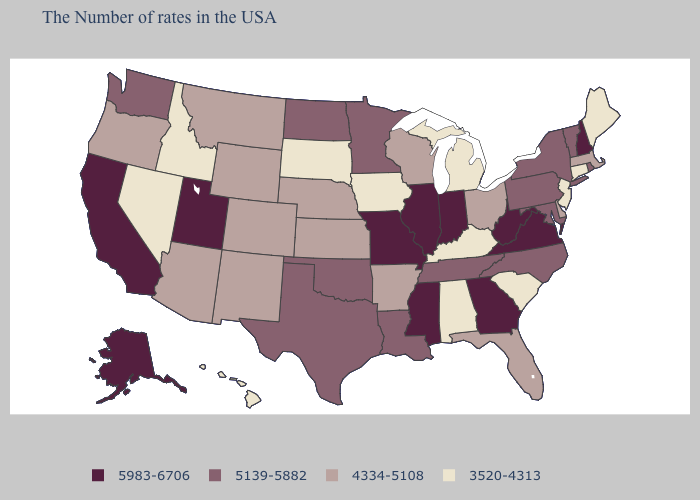Name the states that have a value in the range 3520-4313?
Answer briefly. Maine, Connecticut, New Jersey, South Carolina, Michigan, Kentucky, Alabama, Iowa, South Dakota, Idaho, Nevada, Hawaii. Name the states that have a value in the range 5983-6706?
Give a very brief answer. New Hampshire, Virginia, West Virginia, Georgia, Indiana, Illinois, Mississippi, Missouri, Utah, California, Alaska. Name the states that have a value in the range 4334-5108?
Short answer required. Massachusetts, Delaware, Ohio, Florida, Wisconsin, Arkansas, Kansas, Nebraska, Wyoming, Colorado, New Mexico, Montana, Arizona, Oregon. Does the first symbol in the legend represent the smallest category?
Short answer required. No. What is the value of Arkansas?
Write a very short answer. 4334-5108. Which states have the lowest value in the MidWest?
Give a very brief answer. Michigan, Iowa, South Dakota. Name the states that have a value in the range 5139-5882?
Be succinct. Rhode Island, Vermont, New York, Maryland, Pennsylvania, North Carolina, Tennessee, Louisiana, Minnesota, Oklahoma, Texas, North Dakota, Washington. Which states have the highest value in the USA?
Concise answer only. New Hampshire, Virginia, West Virginia, Georgia, Indiana, Illinois, Mississippi, Missouri, Utah, California, Alaska. What is the lowest value in the South?
Concise answer only. 3520-4313. What is the lowest value in the USA?
Short answer required. 3520-4313. Does Iowa have the same value as Alabama?
Be succinct. Yes. What is the lowest value in states that border Arizona?
Be succinct. 3520-4313. Which states have the lowest value in the USA?
Be succinct. Maine, Connecticut, New Jersey, South Carolina, Michigan, Kentucky, Alabama, Iowa, South Dakota, Idaho, Nevada, Hawaii. What is the value of Montana?
Be succinct. 4334-5108. Does the first symbol in the legend represent the smallest category?
Be succinct. No. 